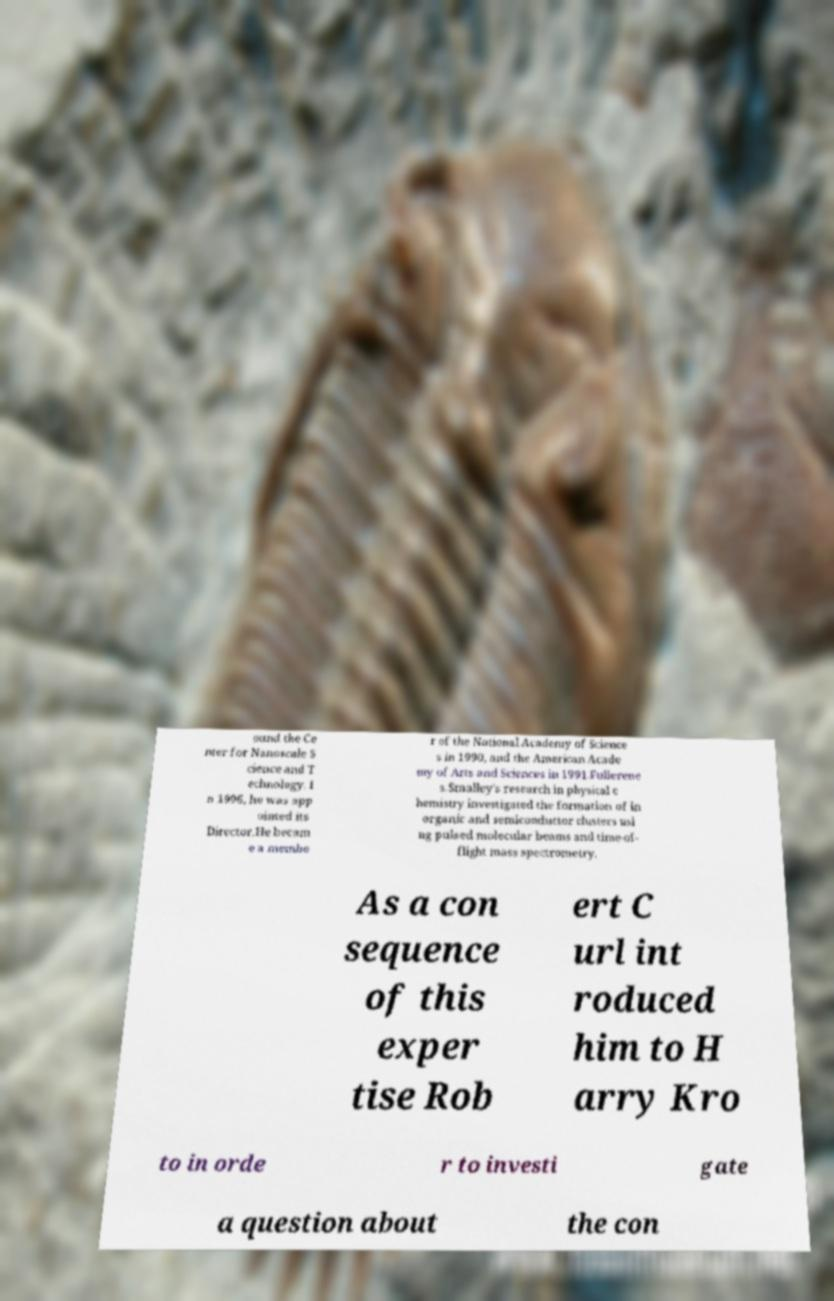For documentation purposes, I need the text within this image transcribed. Could you provide that? ound the Ce nter for Nanoscale S cience and T echnology. I n 1996, he was app ointed its Director.He becam e a membe r of the National Academy of Science s in 1990, and the American Acade my of Arts and Sciences in 1991.Fullerene s.Smalley's research in physical c hemistry investigated the formation of in organic and semiconductor clusters usi ng pulsed molecular beams and time-of- flight mass spectrometry. As a con sequence of this exper tise Rob ert C url int roduced him to H arry Kro to in orde r to investi gate a question about the con 